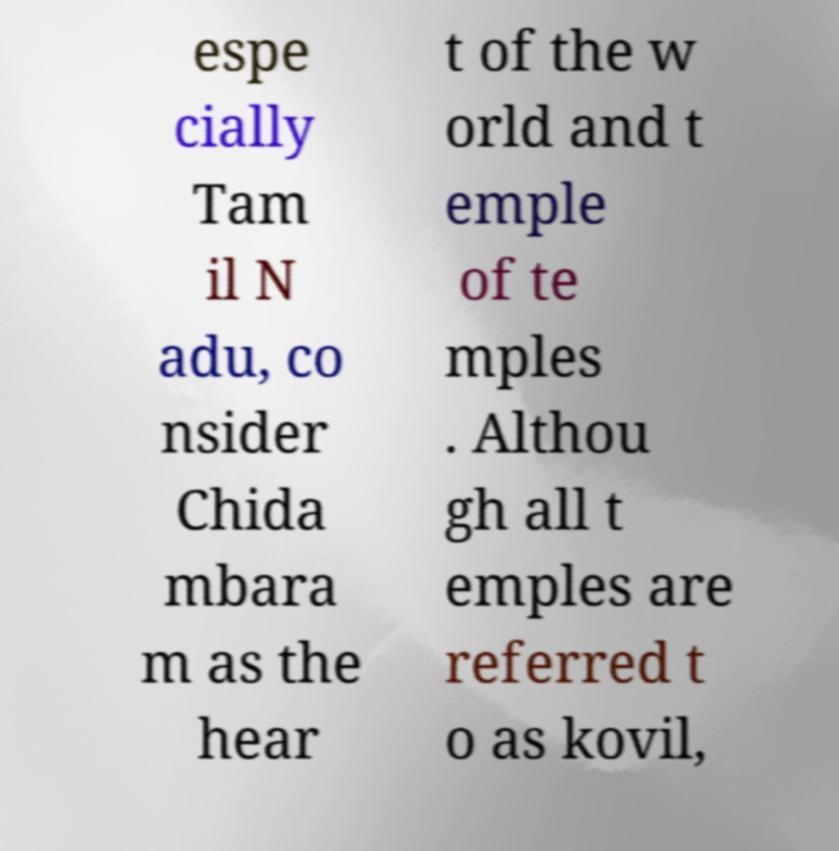I need the written content from this picture converted into text. Can you do that? espe cially Tam il N adu, co nsider Chida mbara m as the hear t of the w orld and t emple of te mples . Althou gh all t emples are referred t o as kovil, 